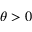Convert formula to latex. <formula><loc_0><loc_0><loc_500><loc_500>\theta > 0</formula> 